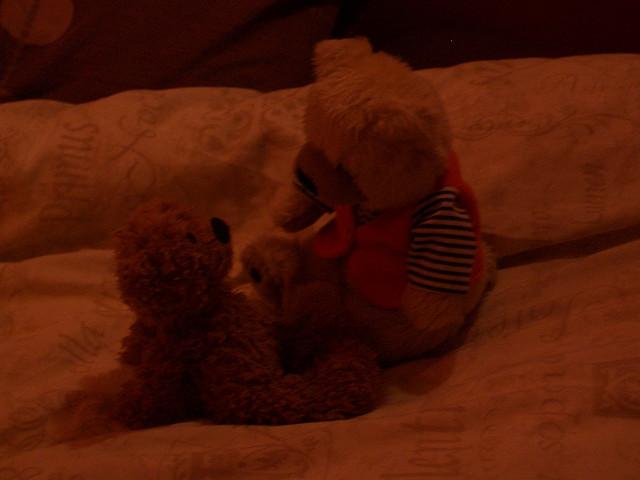How many teddy bears are here?
Write a very short answer. 2. Where are the teddy bears?
Short answer required. On bed. Was this taken by a human or a camera trap?
Answer briefly. Human. Why is the room red?
Be succinct. Lighting. 